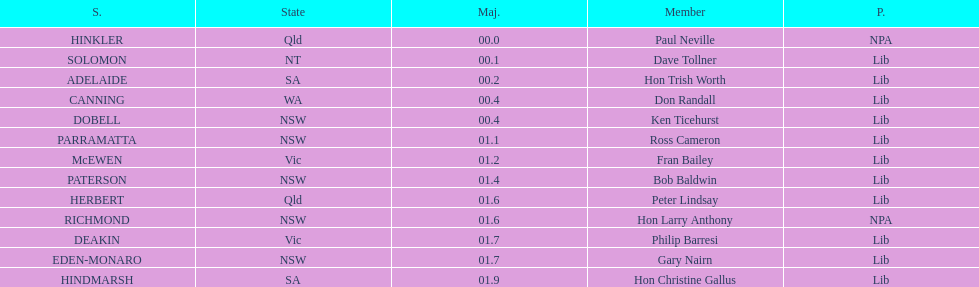What party had the most seats? Lib. 